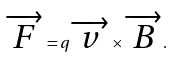Convert formula to latex. <formula><loc_0><loc_0><loc_500><loc_500>\overrightarrow { F } = q \overrightarrow { v } \times \overrightarrow { B } .</formula> 